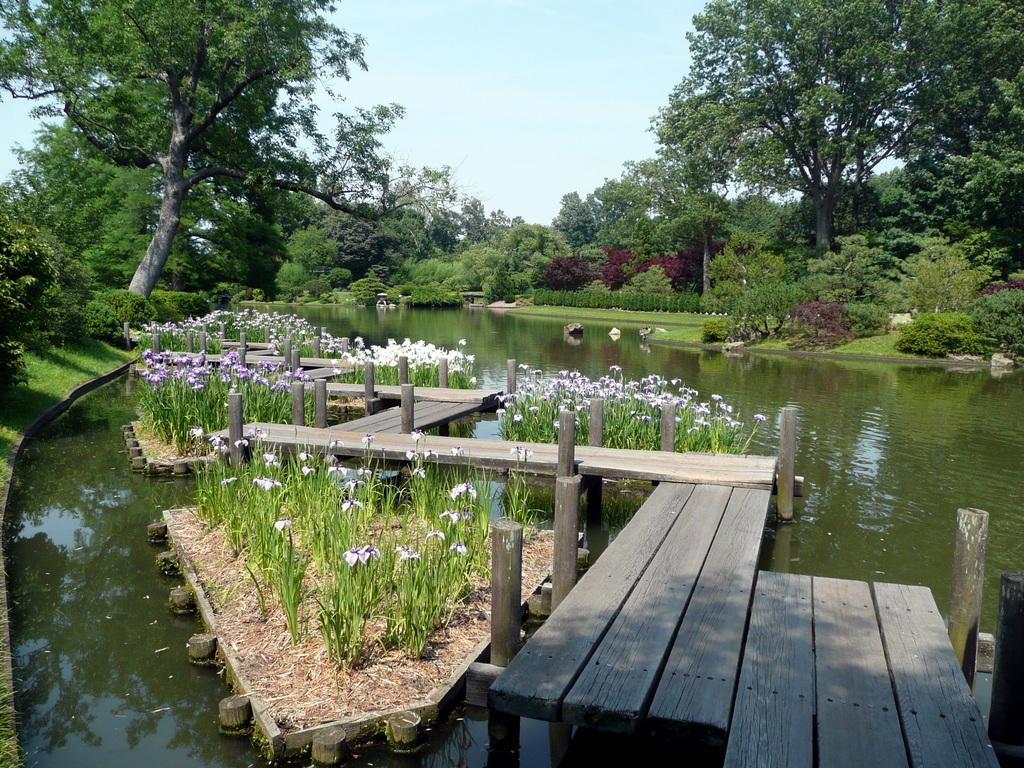What structure is present in the image? There is a bridge in the image. What type of vegetation can be seen in the image? There are plants with flowers in the image. What natural element is visible in the image? There is water visible in the image. What can be seen in the background of the image? There are trees and the sky visible in the background of the image. What type of button can be seen in the middle of the bridge in the image? There is no button present in the image, and the bridge does not have a middle section with a button. 